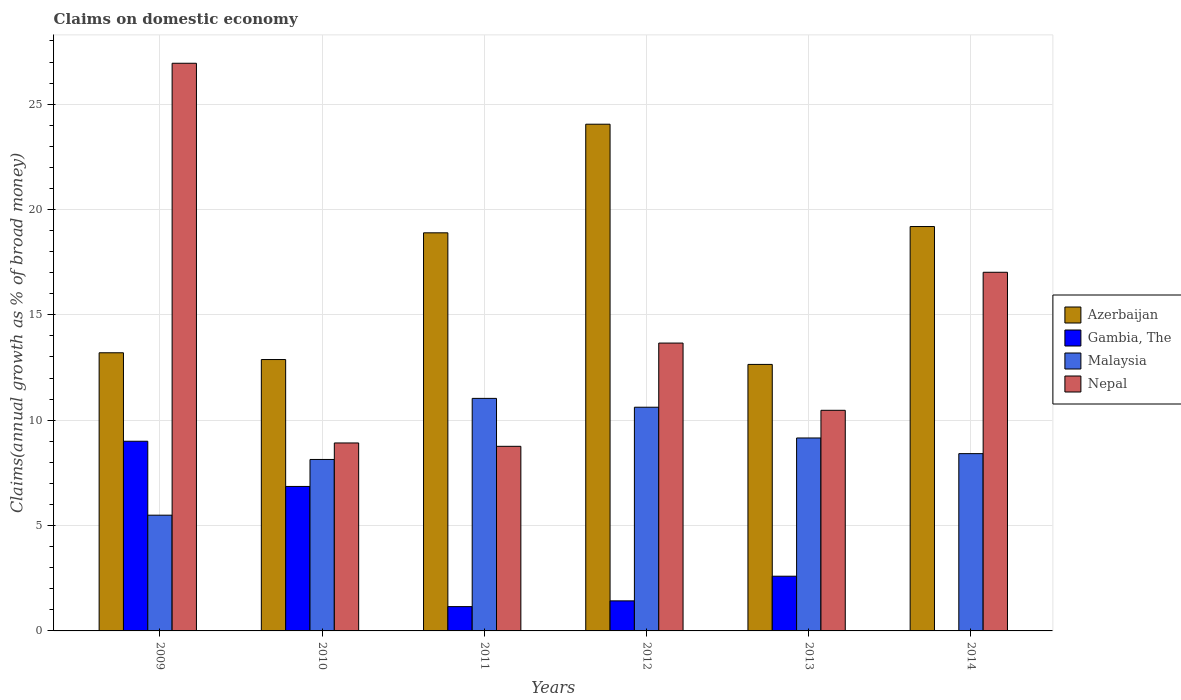How many different coloured bars are there?
Your answer should be compact. 4. How many groups of bars are there?
Your answer should be very brief. 6. How many bars are there on the 2nd tick from the right?
Offer a very short reply. 4. What is the label of the 5th group of bars from the left?
Offer a very short reply. 2013. What is the percentage of broad money claimed on domestic economy in Gambia, The in 2013?
Your answer should be compact. 2.6. Across all years, what is the maximum percentage of broad money claimed on domestic economy in Azerbaijan?
Your response must be concise. 24.05. Across all years, what is the minimum percentage of broad money claimed on domestic economy in Azerbaijan?
Your response must be concise. 12.65. What is the total percentage of broad money claimed on domestic economy in Nepal in the graph?
Ensure brevity in your answer.  85.77. What is the difference between the percentage of broad money claimed on domestic economy in Azerbaijan in 2010 and that in 2013?
Your answer should be compact. 0.23. What is the difference between the percentage of broad money claimed on domestic economy in Malaysia in 2009 and the percentage of broad money claimed on domestic economy in Gambia, The in 2013?
Provide a succinct answer. 2.9. What is the average percentage of broad money claimed on domestic economy in Azerbaijan per year?
Keep it short and to the point. 16.81. In the year 2010, what is the difference between the percentage of broad money claimed on domestic economy in Azerbaijan and percentage of broad money claimed on domestic economy in Gambia, The?
Your answer should be very brief. 6.02. What is the ratio of the percentage of broad money claimed on domestic economy in Malaysia in 2010 to that in 2014?
Make the answer very short. 0.97. Is the difference between the percentage of broad money claimed on domestic economy in Azerbaijan in 2011 and 2013 greater than the difference between the percentage of broad money claimed on domestic economy in Gambia, The in 2011 and 2013?
Provide a short and direct response. Yes. What is the difference between the highest and the second highest percentage of broad money claimed on domestic economy in Malaysia?
Your answer should be compact. 0.42. What is the difference between the highest and the lowest percentage of broad money claimed on domestic economy in Azerbaijan?
Offer a terse response. 11.4. In how many years, is the percentage of broad money claimed on domestic economy in Malaysia greater than the average percentage of broad money claimed on domestic economy in Malaysia taken over all years?
Make the answer very short. 3. How many bars are there?
Provide a short and direct response. 23. Does the graph contain grids?
Provide a short and direct response. Yes. Where does the legend appear in the graph?
Offer a very short reply. Center right. How are the legend labels stacked?
Offer a terse response. Vertical. What is the title of the graph?
Offer a terse response. Claims on domestic economy. What is the label or title of the Y-axis?
Offer a very short reply. Claims(annual growth as % of broad money). What is the Claims(annual growth as % of broad money) in Azerbaijan in 2009?
Your answer should be compact. 13.2. What is the Claims(annual growth as % of broad money) in Gambia, The in 2009?
Your response must be concise. 9. What is the Claims(annual growth as % of broad money) in Malaysia in 2009?
Your answer should be very brief. 5.49. What is the Claims(annual growth as % of broad money) of Nepal in 2009?
Give a very brief answer. 26.94. What is the Claims(annual growth as % of broad money) of Azerbaijan in 2010?
Provide a short and direct response. 12.88. What is the Claims(annual growth as % of broad money) in Gambia, The in 2010?
Offer a very short reply. 6.86. What is the Claims(annual growth as % of broad money) in Malaysia in 2010?
Offer a terse response. 8.14. What is the Claims(annual growth as % of broad money) in Nepal in 2010?
Provide a succinct answer. 8.92. What is the Claims(annual growth as % of broad money) of Azerbaijan in 2011?
Give a very brief answer. 18.89. What is the Claims(annual growth as % of broad money) of Gambia, The in 2011?
Your response must be concise. 1.15. What is the Claims(annual growth as % of broad money) of Malaysia in 2011?
Your answer should be very brief. 11.04. What is the Claims(annual growth as % of broad money) of Nepal in 2011?
Your answer should be compact. 8.76. What is the Claims(annual growth as % of broad money) of Azerbaijan in 2012?
Your answer should be compact. 24.05. What is the Claims(annual growth as % of broad money) in Gambia, The in 2012?
Provide a succinct answer. 1.43. What is the Claims(annual growth as % of broad money) of Malaysia in 2012?
Make the answer very short. 10.62. What is the Claims(annual growth as % of broad money) in Nepal in 2012?
Your answer should be compact. 13.66. What is the Claims(annual growth as % of broad money) in Azerbaijan in 2013?
Your response must be concise. 12.65. What is the Claims(annual growth as % of broad money) in Gambia, The in 2013?
Offer a terse response. 2.6. What is the Claims(annual growth as % of broad money) in Malaysia in 2013?
Your answer should be compact. 9.16. What is the Claims(annual growth as % of broad money) of Nepal in 2013?
Your response must be concise. 10.47. What is the Claims(annual growth as % of broad money) of Azerbaijan in 2014?
Your answer should be very brief. 19.19. What is the Claims(annual growth as % of broad money) of Gambia, The in 2014?
Offer a very short reply. 0. What is the Claims(annual growth as % of broad money) in Malaysia in 2014?
Your answer should be very brief. 8.41. What is the Claims(annual growth as % of broad money) of Nepal in 2014?
Ensure brevity in your answer.  17.02. Across all years, what is the maximum Claims(annual growth as % of broad money) in Azerbaijan?
Provide a succinct answer. 24.05. Across all years, what is the maximum Claims(annual growth as % of broad money) in Gambia, The?
Give a very brief answer. 9. Across all years, what is the maximum Claims(annual growth as % of broad money) in Malaysia?
Your answer should be very brief. 11.04. Across all years, what is the maximum Claims(annual growth as % of broad money) of Nepal?
Offer a very short reply. 26.94. Across all years, what is the minimum Claims(annual growth as % of broad money) in Azerbaijan?
Give a very brief answer. 12.65. Across all years, what is the minimum Claims(annual growth as % of broad money) in Gambia, The?
Provide a short and direct response. 0. Across all years, what is the minimum Claims(annual growth as % of broad money) in Malaysia?
Your answer should be compact. 5.49. Across all years, what is the minimum Claims(annual growth as % of broad money) of Nepal?
Keep it short and to the point. 8.76. What is the total Claims(annual growth as % of broad money) of Azerbaijan in the graph?
Offer a very short reply. 100.86. What is the total Claims(annual growth as % of broad money) in Gambia, The in the graph?
Provide a succinct answer. 21.03. What is the total Claims(annual growth as % of broad money) in Malaysia in the graph?
Provide a succinct answer. 52.85. What is the total Claims(annual growth as % of broad money) in Nepal in the graph?
Give a very brief answer. 85.77. What is the difference between the Claims(annual growth as % of broad money) in Azerbaijan in 2009 and that in 2010?
Give a very brief answer. 0.32. What is the difference between the Claims(annual growth as % of broad money) of Gambia, The in 2009 and that in 2010?
Offer a very short reply. 2.15. What is the difference between the Claims(annual growth as % of broad money) of Malaysia in 2009 and that in 2010?
Make the answer very short. -2.64. What is the difference between the Claims(annual growth as % of broad money) of Nepal in 2009 and that in 2010?
Your response must be concise. 18.02. What is the difference between the Claims(annual growth as % of broad money) of Azerbaijan in 2009 and that in 2011?
Offer a terse response. -5.69. What is the difference between the Claims(annual growth as % of broad money) in Gambia, The in 2009 and that in 2011?
Your answer should be compact. 7.85. What is the difference between the Claims(annual growth as % of broad money) in Malaysia in 2009 and that in 2011?
Your answer should be compact. -5.54. What is the difference between the Claims(annual growth as % of broad money) in Nepal in 2009 and that in 2011?
Ensure brevity in your answer.  18.18. What is the difference between the Claims(annual growth as % of broad money) of Azerbaijan in 2009 and that in 2012?
Your response must be concise. -10.85. What is the difference between the Claims(annual growth as % of broad money) of Gambia, The in 2009 and that in 2012?
Your answer should be compact. 7.58. What is the difference between the Claims(annual growth as % of broad money) in Malaysia in 2009 and that in 2012?
Provide a short and direct response. -5.12. What is the difference between the Claims(annual growth as % of broad money) in Nepal in 2009 and that in 2012?
Give a very brief answer. 13.28. What is the difference between the Claims(annual growth as % of broad money) of Azerbaijan in 2009 and that in 2013?
Your answer should be compact. 0.55. What is the difference between the Claims(annual growth as % of broad money) in Gambia, The in 2009 and that in 2013?
Offer a terse response. 6.41. What is the difference between the Claims(annual growth as % of broad money) in Malaysia in 2009 and that in 2013?
Ensure brevity in your answer.  -3.66. What is the difference between the Claims(annual growth as % of broad money) in Nepal in 2009 and that in 2013?
Offer a terse response. 16.47. What is the difference between the Claims(annual growth as % of broad money) in Azerbaijan in 2009 and that in 2014?
Your answer should be very brief. -5.99. What is the difference between the Claims(annual growth as % of broad money) in Malaysia in 2009 and that in 2014?
Offer a very short reply. -2.92. What is the difference between the Claims(annual growth as % of broad money) of Nepal in 2009 and that in 2014?
Ensure brevity in your answer.  9.92. What is the difference between the Claims(annual growth as % of broad money) of Azerbaijan in 2010 and that in 2011?
Your answer should be very brief. -6.01. What is the difference between the Claims(annual growth as % of broad money) of Gambia, The in 2010 and that in 2011?
Offer a terse response. 5.7. What is the difference between the Claims(annual growth as % of broad money) of Malaysia in 2010 and that in 2011?
Your response must be concise. -2.9. What is the difference between the Claims(annual growth as % of broad money) in Nepal in 2010 and that in 2011?
Offer a very short reply. 0.16. What is the difference between the Claims(annual growth as % of broad money) of Azerbaijan in 2010 and that in 2012?
Offer a very short reply. -11.17. What is the difference between the Claims(annual growth as % of broad money) of Gambia, The in 2010 and that in 2012?
Offer a terse response. 5.43. What is the difference between the Claims(annual growth as % of broad money) in Malaysia in 2010 and that in 2012?
Give a very brief answer. -2.48. What is the difference between the Claims(annual growth as % of broad money) of Nepal in 2010 and that in 2012?
Keep it short and to the point. -4.74. What is the difference between the Claims(annual growth as % of broad money) in Azerbaijan in 2010 and that in 2013?
Provide a succinct answer. 0.23. What is the difference between the Claims(annual growth as % of broad money) of Gambia, The in 2010 and that in 2013?
Your answer should be compact. 4.26. What is the difference between the Claims(annual growth as % of broad money) in Malaysia in 2010 and that in 2013?
Provide a succinct answer. -1.02. What is the difference between the Claims(annual growth as % of broad money) of Nepal in 2010 and that in 2013?
Keep it short and to the point. -1.55. What is the difference between the Claims(annual growth as % of broad money) in Azerbaijan in 2010 and that in 2014?
Ensure brevity in your answer.  -6.31. What is the difference between the Claims(annual growth as % of broad money) in Malaysia in 2010 and that in 2014?
Keep it short and to the point. -0.28. What is the difference between the Claims(annual growth as % of broad money) in Nepal in 2010 and that in 2014?
Provide a succinct answer. -8.1. What is the difference between the Claims(annual growth as % of broad money) of Azerbaijan in 2011 and that in 2012?
Provide a short and direct response. -5.16. What is the difference between the Claims(annual growth as % of broad money) in Gambia, The in 2011 and that in 2012?
Keep it short and to the point. -0.27. What is the difference between the Claims(annual growth as % of broad money) in Malaysia in 2011 and that in 2012?
Make the answer very short. 0.42. What is the difference between the Claims(annual growth as % of broad money) of Nepal in 2011 and that in 2012?
Your response must be concise. -4.9. What is the difference between the Claims(annual growth as % of broad money) of Azerbaijan in 2011 and that in 2013?
Offer a very short reply. 6.25. What is the difference between the Claims(annual growth as % of broad money) of Gambia, The in 2011 and that in 2013?
Your answer should be very brief. -1.44. What is the difference between the Claims(annual growth as % of broad money) in Malaysia in 2011 and that in 2013?
Your answer should be very brief. 1.88. What is the difference between the Claims(annual growth as % of broad money) in Nepal in 2011 and that in 2013?
Keep it short and to the point. -1.71. What is the difference between the Claims(annual growth as % of broad money) in Azerbaijan in 2011 and that in 2014?
Your response must be concise. -0.3. What is the difference between the Claims(annual growth as % of broad money) in Malaysia in 2011 and that in 2014?
Keep it short and to the point. 2.62. What is the difference between the Claims(annual growth as % of broad money) of Nepal in 2011 and that in 2014?
Provide a succinct answer. -8.26. What is the difference between the Claims(annual growth as % of broad money) of Azerbaijan in 2012 and that in 2013?
Your response must be concise. 11.4. What is the difference between the Claims(annual growth as % of broad money) of Gambia, The in 2012 and that in 2013?
Give a very brief answer. -1.17. What is the difference between the Claims(annual growth as % of broad money) of Malaysia in 2012 and that in 2013?
Offer a terse response. 1.46. What is the difference between the Claims(annual growth as % of broad money) of Nepal in 2012 and that in 2013?
Your answer should be compact. 3.19. What is the difference between the Claims(annual growth as % of broad money) in Azerbaijan in 2012 and that in 2014?
Give a very brief answer. 4.86. What is the difference between the Claims(annual growth as % of broad money) of Malaysia in 2012 and that in 2014?
Your response must be concise. 2.2. What is the difference between the Claims(annual growth as % of broad money) of Nepal in 2012 and that in 2014?
Provide a succinct answer. -3.36. What is the difference between the Claims(annual growth as % of broad money) in Azerbaijan in 2013 and that in 2014?
Your response must be concise. -6.54. What is the difference between the Claims(annual growth as % of broad money) in Malaysia in 2013 and that in 2014?
Offer a very short reply. 0.74. What is the difference between the Claims(annual growth as % of broad money) in Nepal in 2013 and that in 2014?
Your answer should be very brief. -6.55. What is the difference between the Claims(annual growth as % of broad money) in Azerbaijan in 2009 and the Claims(annual growth as % of broad money) in Gambia, The in 2010?
Ensure brevity in your answer.  6.34. What is the difference between the Claims(annual growth as % of broad money) of Azerbaijan in 2009 and the Claims(annual growth as % of broad money) of Malaysia in 2010?
Provide a succinct answer. 5.06. What is the difference between the Claims(annual growth as % of broad money) of Azerbaijan in 2009 and the Claims(annual growth as % of broad money) of Nepal in 2010?
Provide a short and direct response. 4.28. What is the difference between the Claims(annual growth as % of broad money) of Gambia, The in 2009 and the Claims(annual growth as % of broad money) of Malaysia in 2010?
Offer a very short reply. 0.86. What is the difference between the Claims(annual growth as % of broad money) of Gambia, The in 2009 and the Claims(annual growth as % of broad money) of Nepal in 2010?
Your answer should be very brief. 0.08. What is the difference between the Claims(annual growth as % of broad money) in Malaysia in 2009 and the Claims(annual growth as % of broad money) in Nepal in 2010?
Provide a succinct answer. -3.43. What is the difference between the Claims(annual growth as % of broad money) in Azerbaijan in 2009 and the Claims(annual growth as % of broad money) in Gambia, The in 2011?
Your answer should be very brief. 12.05. What is the difference between the Claims(annual growth as % of broad money) in Azerbaijan in 2009 and the Claims(annual growth as % of broad money) in Malaysia in 2011?
Provide a short and direct response. 2.16. What is the difference between the Claims(annual growth as % of broad money) in Azerbaijan in 2009 and the Claims(annual growth as % of broad money) in Nepal in 2011?
Your answer should be compact. 4.44. What is the difference between the Claims(annual growth as % of broad money) of Gambia, The in 2009 and the Claims(annual growth as % of broad money) of Malaysia in 2011?
Your response must be concise. -2.03. What is the difference between the Claims(annual growth as % of broad money) of Gambia, The in 2009 and the Claims(annual growth as % of broad money) of Nepal in 2011?
Offer a very short reply. 0.24. What is the difference between the Claims(annual growth as % of broad money) in Malaysia in 2009 and the Claims(annual growth as % of broad money) in Nepal in 2011?
Offer a very short reply. -3.27. What is the difference between the Claims(annual growth as % of broad money) in Azerbaijan in 2009 and the Claims(annual growth as % of broad money) in Gambia, The in 2012?
Provide a succinct answer. 11.77. What is the difference between the Claims(annual growth as % of broad money) of Azerbaijan in 2009 and the Claims(annual growth as % of broad money) of Malaysia in 2012?
Offer a very short reply. 2.58. What is the difference between the Claims(annual growth as % of broad money) of Azerbaijan in 2009 and the Claims(annual growth as % of broad money) of Nepal in 2012?
Ensure brevity in your answer.  -0.46. What is the difference between the Claims(annual growth as % of broad money) in Gambia, The in 2009 and the Claims(annual growth as % of broad money) in Malaysia in 2012?
Offer a very short reply. -1.61. What is the difference between the Claims(annual growth as % of broad money) in Gambia, The in 2009 and the Claims(annual growth as % of broad money) in Nepal in 2012?
Offer a terse response. -4.66. What is the difference between the Claims(annual growth as % of broad money) of Malaysia in 2009 and the Claims(annual growth as % of broad money) of Nepal in 2012?
Provide a succinct answer. -8.17. What is the difference between the Claims(annual growth as % of broad money) in Azerbaijan in 2009 and the Claims(annual growth as % of broad money) in Gambia, The in 2013?
Your response must be concise. 10.6. What is the difference between the Claims(annual growth as % of broad money) of Azerbaijan in 2009 and the Claims(annual growth as % of broad money) of Malaysia in 2013?
Ensure brevity in your answer.  4.04. What is the difference between the Claims(annual growth as % of broad money) in Azerbaijan in 2009 and the Claims(annual growth as % of broad money) in Nepal in 2013?
Provide a short and direct response. 2.73. What is the difference between the Claims(annual growth as % of broad money) of Gambia, The in 2009 and the Claims(annual growth as % of broad money) of Malaysia in 2013?
Provide a short and direct response. -0.15. What is the difference between the Claims(annual growth as % of broad money) of Gambia, The in 2009 and the Claims(annual growth as % of broad money) of Nepal in 2013?
Give a very brief answer. -1.47. What is the difference between the Claims(annual growth as % of broad money) in Malaysia in 2009 and the Claims(annual growth as % of broad money) in Nepal in 2013?
Keep it short and to the point. -4.98. What is the difference between the Claims(annual growth as % of broad money) of Azerbaijan in 2009 and the Claims(annual growth as % of broad money) of Malaysia in 2014?
Ensure brevity in your answer.  4.79. What is the difference between the Claims(annual growth as % of broad money) in Azerbaijan in 2009 and the Claims(annual growth as % of broad money) in Nepal in 2014?
Give a very brief answer. -3.82. What is the difference between the Claims(annual growth as % of broad money) in Gambia, The in 2009 and the Claims(annual growth as % of broad money) in Malaysia in 2014?
Ensure brevity in your answer.  0.59. What is the difference between the Claims(annual growth as % of broad money) of Gambia, The in 2009 and the Claims(annual growth as % of broad money) of Nepal in 2014?
Keep it short and to the point. -8.02. What is the difference between the Claims(annual growth as % of broad money) in Malaysia in 2009 and the Claims(annual growth as % of broad money) in Nepal in 2014?
Keep it short and to the point. -11.53. What is the difference between the Claims(annual growth as % of broad money) in Azerbaijan in 2010 and the Claims(annual growth as % of broad money) in Gambia, The in 2011?
Make the answer very short. 11.73. What is the difference between the Claims(annual growth as % of broad money) in Azerbaijan in 2010 and the Claims(annual growth as % of broad money) in Malaysia in 2011?
Offer a very short reply. 1.84. What is the difference between the Claims(annual growth as % of broad money) in Azerbaijan in 2010 and the Claims(annual growth as % of broad money) in Nepal in 2011?
Provide a short and direct response. 4.12. What is the difference between the Claims(annual growth as % of broad money) in Gambia, The in 2010 and the Claims(annual growth as % of broad money) in Malaysia in 2011?
Give a very brief answer. -4.18. What is the difference between the Claims(annual growth as % of broad money) in Gambia, The in 2010 and the Claims(annual growth as % of broad money) in Nepal in 2011?
Give a very brief answer. -1.9. What is the difference between the Claims(annual growth as % of broad money) of Malaysia in 2010 and the Claims(annual growth as % of broad money) of Nepal in 2011?
Give a very brief answer. -0.62. What is the difference between the Claims(annual growth as % of broad money) of Azerbaijan in 2010 and the Claims(annual growth as % of broad money) of Gambia, The in 2012?
Provide a succinct answer. 11.45. What is the difference between the Claims(annual growth as % of broad money) in Azerbaijan in 2010 and the Claims(annual growth as % of broad money) in Malaysia in 2012?
Make the answer very short. 2.26. What is the difference between the Claims(annual growth as % of broad money) of Azerbaijan in 2010 and the Claims(annual growth as % of broad money) of Nepal in 2012?
Give a very brief answer. -0.78. What is the difference between the Claims(annual growth as % of broad money) of Gambia, The in 2010 and the Claims(annual growth as % of broad money) of Malaysia in 2012?
Your answer should be compact. -3.76. What is the difference between the Claims(annual growth as % of broad money) in Gambia, The in 2010 and the Claims(annual growth as % of broad money) in Nepal in 2012?
Keep it short and to the point. -6.8. What is the difference between the Claims(annual growth as % of broad money) in Malaysia in 2010 and the Claims(annual growth as % of broad money) in Nepal in 2012?
Provide a short and direct response. -5.52. What is the difference between the Claims(annual growth as % of broad money) of Azerbaijan in 2010 and the Claims(annual growth as % of broad money) of Gambia, The in 2013?
Provide a short and direct response. 10.28. What is the difference between the Claims(annual growth as % of broad money) of Azerbaijan in 2010 and the Claims(annual growth as % of broad money) of Malaysia in 2013?
Your answer should be very brief. 3.72. What is the difference between the Claims(annual growth as % of broad money) in Azerbaijan in 2010 and the Claims(annual growth as % of broad money) in Nepal in 2013?
Give a very brief answer. 2.41. What is the difference between the Claims(annual growth as % of broad money) of Gambia, The in 2010 and the Claims(annual growth as % of broad money) of Malaysia in 2013?
Offer a very short reply. -2.3. What is the difference between the Claims(annual growth as % of broad money) in Gambia, The in 2010 and the Claims(annual growth as % of broad money) in Nepal in 2013?
Make the answer very short. -3.61. What is the difference between the Claims(annual growth as % of broad money) of Malaysia in 2010 and the Claims(annual growth as % of broad money) of Nepal in 2013?
Keep it short and to the point. -2.33. What is the difference between the Claims(annual growth as % of broad money) of Azerbaijan in 2010 and the Claims(annual growth as % of broad money) of Malaysia in 2014?
Keep it short and to the point. 4.47. What is the difference between the Claims(annual growth as % of broad money) in Azerbaijan in 2010 and the Claims(annual growth as % of broad money) in Nepal in 2014?
Your response must be concise. -4.14. What is the difference between the Claims(annual growth as % of broad money) of Gambia, The in 2010 and the Claims(annual growth as % of broad money) of Malaysia in 2014?
Provide a short and direct response. -1.56. What is the difference between the Claims(annual growth as % of broad money) in Gambia, The in 2010 and the Claims(annual growth as % of broad money) in Nepal in 2014?
Offer a very short reply. -10.16. What is the difference between the Claims(annual growth as % of broad money) in Malaysia in 2010 and the Claims(annual growth as % of broad money) in Nepal in 2014?
Offer a very short reply. -8.88. What is the difference between the Claims(annual growth as % of broad money) of Azerbaijan in 2011 and the Claims(annual growth as % of broad money) of Gambia, The in 2012?
Keep it short and to the point. 17.47. What is the difference between the Claims(annual growth as % of broad money) in Azerbaijan in 2011 and the Claims(annual growth as % of broad money) in Malaysia in 2012?
Offer a very short reply. 8.28. What is the difference between the Claims(annual growth as % of broad money) in Azerbaijan in 2011 and the Claims(annual growth as % of broad money) in Nepal in 2012?
Give a very brief answer. 5.23. What is the difference between the Claims(annual growth as % of broad money) of Gambia, The in 2011 and the Claims(annual growth as % of broad money) of Malaysia in 2012?
Your answer should be very brief. -9.46. What is the difference between the Claims(annual growth as % of broad money) of Gambia, The in 2011 and the Claims(annual growth as % of broad money) of Nepal in 2012?
Make the answer very short. -12.51. What is the difference between the Claims(annual growth as % of broad money) in Malaysia in 2011 and the Claims(annual growth as % of broad money) in Nepal in 2012?
Make the answer very short. -2.63. What is the difference between the Claims(annual growth as % of broad money) in Azerbaijan in 2011 and the Claims(annual growth as % of broad money) in Gambia, The in 2013?
Provide a short and direct response. 16.3. What is the difference between the Claims(annual growth as % of broad money) of Azerbaijan in 2011 and the Claims(annual growth as % of broad money) of Malaysia in 2013?
Your response must be concise. 9.74. What is the difference between the Claims(annual growth as % of broad money) of Azerbaijan in 2011 and the Claims(annual growth as % of broad money) of Nepal in 2013?
Provide a short and direct response. 8.42. What is the difference between the Claims(annual growth as % of broad money) in Gambia, The in 2011 and the Claims(annual growth as % of broad money) in Malaysia in 2013?
Your answer should be very brief. -8. What is the difference between the Claims(annual growth as % of broad money) of Gambia, The in 2011 and the Claims(annual growth as % of broad money) of Nepal in 2013?
Your response must be concise. -9.32. What is the difference between the Claims(annual growth as % of broad money) in Malaysia in 2011 and the Claims(annual growth as % of broad money) in Nepal in 2013?
Give a very brief answer. 0.57. What is the difference between the Claims(annual growth as % of broad money) in Azerbaijan in 2011 and the Claims(annual growth as % of broad money) in Malaysia in 2014?
Keep it short and to the point. 10.48. What is the difference between the Claims(annual growth as % of broad money) of Azerbaijan in 2011 and the Claims(annual growth as % of broad money) of Nepal in 2014?
Your response must be concise. 1.87. What is the difference between the Claims(annual growth as % of broad money) in Gambia, The in 2011 and the Claims(annual growth as % of broad money) in Malaysia in 2014?
Provide a succinct answer. -7.26. What is the difference between the Claims(annual growth as % of broad money) of Gambia, The in 2011 and the Claims(annual growth as % of broad money) of Nepal in 2014?
Provide a succinct answer. -15.87. What is the difference between the Claims(annual growth as % of broad money) in Malaysia in 2011 and the Claims(annual growth as % of broad money) in Nepal in 2014?
Keep it short and to the point. -5.99. What is the difference between the Claims(annual growth as % of broad money) in Azerbaijan in 2012 and the Claims(annual growth as % of broad money) in Gambia, The in 2013?
Provide a succinct answer. 21.45. What is the difference between the Claims(annual growth as % of broad money) of Azerbaijan in 2012 and the Claims(annual growth as % of broad money) of Malaysia in 2013?
Keep it short and to the point. 14.89. What is the difference between the Claims(annual growth as % of broad money) in Azerbaijan in 2012 and the Claims(annual growth as % of broad money) in Nepal in 2013?
Provide a succinct answer. 13.58. What is the difference between the Claims(annual growth as % of broad money) in Gambia, The in 2012 and the Claims(annual growth as % of broad money) in Malaysia in 2013?
Your response must be concise. -7.73. What is the difference between the Claims(annual growth as % of broad money) in Gambia, The in 2012 and the Claims(annual growth as % of broad money) in Nepal in 2013?
Your response must be concise. -9.04. What is the difference between the Claims(annual growth as % of broad money) of Malaysia in 2012 and the Claims(annual growth as % of broad money) of Nepal in 2013?
Make the answer very short. 0.15. What is the difference between the Claims(annual growth as % of broad money) of Azerbaijan in 2012 and the Claims(annual growth as % of broad money) of Malaysia in 2014?
Offer a terse response. 15.63. What is the difference between the Claims(annual growth as % of broad money) of Azerbaijan in 2012 and the Claims(annual growth as % of broad money) of Nepal in 2014?
Offer a very short reply. 7.03. What is the difference between the Claims(annual growth as % of broad money) of Gambia, The in 2012 and the Claims(annual growth as % of broad money) of Malaysia in 2014?
Keep it short and to the point. -6.99. What is the difference between the Claims(annual growth as % of broad money) in Gambia, The in 2012 and the Claims(annual growth as % of broad money) in Nepal in 2014?
Your response must be concise. -15.59. What is the difference between the Claims(annual growth as % of broad money) in Malaysia in 2012 and the Claims(annual growth as % of broad money) in Nepal in 2014?
Ensure brevity in your answer.  -6.41. What is the difference between the Claims(annual growth as % of broad money) of Azerbaijan in 2013 and the Claims(annual growth as % of broad money) of Malaysia in 2014?
Provide a short and direct response. 4.23. What is the difference between the Claims(annual growth as % of broad money) of Azerbaijan in 2013 and the Claims(annual growth as % of broad money) of Nepal in 2014?
Give a very brief answer. -4.37. What is the difference between the Claims(annual growth as % of broad money) of Gambia, The in 2013 and the Claims(annual growth as % of broad money) of Malaysia in 2014?
Ensure brevity in your answer.  -5.82. What is the difference between the Claims(annual growth as % of broad money) in Gambia, The in 2013 and the Claims(annual growth as % of broad money) in Nepal in 2014?
Your answer should be compact. -14.42. What is the difference between the Claims(annual growth as % of broad money) in Malaysia in 2013 and the Claims(annual growth as % of broad money) in Nepal in 2014?
Your response must be concise. -7.86. What is the average Claims(annual growth as % of broad money) in Azerbaijan per year?
Offer a terse response. 16.81. What is the average Claims(annual growth as % of broad money) in Gambia, The per year?
Provide a short and direct response. 3.51. What is the average Claims(annual growth as % of broad money) in Malaysia per year?
Ensure brevity in your answer.  8.81. What is the average Claims(annual growth as % of broad money) of Nepal per year?
Give a very brief answer. 14.3. In the year 2009, what is the difference between the Claims(annual growth as % of broad money) in Azerbaijan and Claims(annual growth as % of broad money) in Gambia, The?
Offer a very short reply. 4.2. In the year 2009, what is the difference between the Claims(annual growth as % of broad money) of Azerbaijan and Claims(annual growth as % of broad money) of Malaysia?
Offer a very short reply. 7.71. In the year 2009, what is the difference between the Claims(annual growth as % of broad money) of Azerbaijan and Claims(annual growth as % of broad money) of Nepal?
Offer a terse response. -13.74. In the year 2009, what is the difference between the Claims(annual growth as % of broad money) in Gambia, The and Claims(annual growth as % of broad money) in Malaysia?
Provide a short and direct response. 3.51. In the year 2009, what is the difference between the Claims(annual growth as % of broad money) of Gambia, The and Claims(annual growth as % of broad money) of Nepal?
Make the answer very short. -17.94. In the year 2009, what is the difference between the Claims(annual growth as % of broad money) of Malaysia and Claims(annual growth as % of broad money) of Nepal?
Give a very brief answer. -21.45. In the year 2010, what is the difference between the Claims(annual growth as % of broad money) in Azerbaijan and Claims(annual growth as % of broad money) in Gambia, The?
Make the answer very short. 6.02. In the year 2010, what is the difference between the Claims(annual growth as % of broad money) of Azerbaijan and Claims(annual growth as % of broad money) of Malaysia?
Ensure brevity in your answer.  4.74. In the year 2010, what is the difference between the Claims(annual growth as % of broad money) in Azerbaijan and Claims(annual growth as % of broad money) in Nepal?
Provide a succinct answer. 3.96. In the year 2010, what is the difference between the Claims(annual growth as % of broad money) in Gambia, The and Claims(annual growth as % of broad money) in Malaysia?
Your answer should be very brief. -1.28. In the year 2010, what is the difference between the Claims(annual growth as % of broad money) of Gambia, The and Claims(annual growth as % of broad money) of Nepal?
Offer a terse response. -2.06. In the year 2010, what is the difference between the Claims(annual growth as % of broad money) of Malaysia and Claims(annual growth as % of broad money) of Nepal?
Your response must be concise. -0.78. In the year 2011, what is the difference between the Claims(annual growth as % of broad money) in Azerbaijan and Claims(annual growth as % of broad money) in Gambia, The?
Keep it short and to the point. 17.74. In the year 2011, what is the difference between the Claims(annual growth as % of broad money) in Azerbaijan and Claims(annual growth as % of broad money) in Malaysia?
Provide a succinct answer. 7.86. In the year 2011, what is the difference between the Claims(annual growth as % of broad money) of Azerbaijan and Claims(annual growth as % of broad money) of Nepal?
Your response must be concise. 10.13. In the year 2011, what is the difference between the Claims(annual growth as % of broad money) in Gambia, The and Claims(annual growth as % of broad money) in Malaysia?
Your answer should be compact. -9.88. In the year 2011, what is the difference between the Claims(annual growth as % of broad money) in Gambia, The and Claims(annual growth as % of broad money) in Nepal?
Provide a short and direct response. -7.61. In the year 2011, what is the difference between the Claims(annual growth as % of broad money) in Malaysia and Claims(annual growth as % of broad money) in Nepal?
Make the answer very short. 2.27. In the year 2012, what is the difference between the Claims(annual growth as % of broad money) of Azerbaijan and Claims(annual growth as % of broad money) of Gambia, The?
Your answer should be very brief. 22.62. In the year 2012, what is the difference between the Claims(annual growth as % of broad money) in Azerbaijan and Claims(annual growth as % of broad money) in Malaysia?
Make the answer very short. 13.43. In the year 2012, what is the difference between the Claims(annual growth as % of broad money) of Azerbaijan and Claims(annual growth as % of broad money) of Nepal?
Offer a terse response. 10.39. In the year 2012, what is the difference between the Claims(annual growth as % of broad money) of Gambia, The and Claims(annual growth as % of broad money) of Malaysia?
Ensure brevity in your answer.  -9.19. In the year 2012, what is the difference between the Claims(annual growth as % of broad money) in Gambia, The and Claims(annual growth as % of broad money) in Nepal?
Your answer should be compact. -12.23. In the year 2012, what is the difference between the Claims(annual growth as % of broad money) of Malaysia and Claims(annual growth as % of broad money) of Nepal?
Offer a very short reply. -3.05. In the year 2013, what is the difference between the Claims(annual growth as % of broad money) in Azerbaijan and Claims(annual growth as % of broad money) in Gambia, The?
Ensure brevity in your answer.  10.05. In the year 2013, what is the difference between the Claims(annual growth as % of broad money) in Azerbaijan and Claims(annual growth as % of broad money) in Malaysia?
Keep it short and to the point. 3.49. In the year 2013, what is the difference between the Claims(annual growth as % of broad money) in Azerbaijan and Claims(annual growth as % of broad money) in Nepal?
Provide a short and direct response. 2.18. In the year 2013, what is the difference between the Claims(annual growth as % of broad money) of Gambia, The and Claims(annual growth as % of broad money) of Malaysia?
Your answer should be compact. -6.56. In the year 2013, what is the difference between the Claims(annual growth as % of broad money) of Gambia, The and Claims(annual growth as % of broad money) of Nepal?
Give a very brief answer. -7.87. In the year 2013, what is the difference between the Claims(annual growth as % of broad money) of Malaysia and Claims(annual growth as % of broad money) of Nepal?
Your answer should be compact. -1.31. In the year 2014, what is the difference between the Claims(annual growth as % of broad money) in Azerbaijan and Claims(annual growth as % of broad money) in Malaysia?
Ensure brevity in your answer.  10.78. In the year 2014, what is the difference between the Claims(annual growth as % of broad money) of Azerbaijan and Claims(annual growth as % of broad money) of Nepal?
Provide a succinct answer. 2.17. In the year 2014, what is the difference between the Claims(annual growth as % of broad money) in Malaysia and Claims(annual growth as % of broad money) in Nepal?
Give a very brief answer. -8.61. What is the ratio of the Claims(annual growth as % of broad money) of Azerbaijan in 2009 to that in 2010?
Make the answer very short. 1.02. What is the ratio of the Claims(annual growth as % of broad money) of Gambia, The in 2009 to that in 2010?
Offer a terse response. 1.31. What is the ratio of the Claims(annual growth as % of broad money) of Malaysia in 2009 to that in 2010?
Keep it short and to the point. 0.68. What is the ratio of the Claims(annual growth as % of broad money) of Nepal in 2009 to that in 2010?
Make the answer very short. 3.02. What is the ratio of the Claims(annual growth as % of broad money) of Azerbaijan in 2009 to that in 2011?
Make the answer very short. 0.7. What is the ratio of the Claims(annual growth as % of broad money) in Gambia, The in 2009 to that in 2011?
Your answer should be compact. 7.81. What is the ratio of the Claims(annual growth as % of broad money) of Malaysia in 2009 to that in 2011?
Provide a short and direct response. 0.5. What is the ratio of the Claims(annual growth as % of broad money) in Nepal in 2009 to that in 2011?
Your response must be concise. 3.08. What is the ratio of the Claims(annual growth as % of broad money) in Azerbaijan in 2009 to that in 2012?
Make the answer very short. 0.55. What is the ratio of the Claims(annual growth as % of broad money) in Gambia, The in 2009 to that in 2012?
Provide a succinct answer. 6.31. What is the ratio of the Claims(annual growth as % of broad money) in Malaysia in 2009 to that in 2012?
Provide a short and direct response. 0.52. What is the ratio of the Claims(annual growth as % of broad money) of Nepal in 2009 to that in 2012?
Ensure brevity in your answer.  1.97. What is the ratio of the Claims(annual growth as % of broad money) of Azerbaijan in 2009 to that in 2013?
Provide a succinct answer. 1.04. What is the ratio of the Claims(annual growth as % of broad money) of Gambia, The in 2009 to that in 2013?
Your answer should be very brief. 3.47. What is the ratio of the Claims(annual growth as % of broad money) in Malaysia in 2009 to that in 2013?
Provide a short and direct response. 0.6. What is the ratio of the Claims(annual growth as % of broad money) of Nepal in 2009 to that in 2013?
Your answer should be very brief. 2.57. What is the ratio of the Claims(annual growth as % of broad money) of Azerbaijan in 2009 to that in 2014?
Your response must be concise. 0.69. What is the ratio of the Claims(annual growth as % of broad money) of Malaysia in 2009 to that in 2014?
Provide a short and direct response. 0.65. What is the ratio of the Claims(annual growth as % of broad money) in Nepal in 2009 to that in 2014?
Provide a succinct answer. 1.58. What is the ratio of the Claims(annual growth as % of broad money) of Azerbaijan in 2010 to that in 2011?
Provide a succinct answer. 0.68. What is the ratio of the Claims(annual growth as % of broad money) in Gambia, The in 2010 to that in 2011?
Your answer should be compact. 5.95. What is the ratio of the Claims(annual growth as % of broad money) of Malaysia in 2010 to that in 2011?
Offer a very short reply. 0.74. What is the ratio of the Claims(annual growth as % of broad money) in Nepal in 2010 to that in 2011?
Make the answer very short. 1.02. What is the ratio of the Claims(annual growth as % of broad money) of Azerbaijan in 2010 to that in 2012?
Your response must be concise. 0.54. What is the ratio of the Claims(annual growth as % of broad money) in Gambia, The in 2010 to that in 2012?
Make the answer very short. 4.81. What is the ratio of the Claims(annual growth as % of broad money) in Malaysia in 2010 to that in 2012?
Provide a succinct answer. 0.77. What is the ratio of the Claims(annual growth as % of broad money) of Nepal in 2010 to that in 2012?
Keep it short and to the point. 0.65. What is the ratio of the Claims(annual growth as % of broad money) of Azerbaijan in 2010 to that in 2013?
Offer a terse response. 1.02. What is the ratio of the Claims(annual growth as % of broad money) in Gambia, The in 2010 to that in 2013?
Offer a terse response. 2.64. What is the ratio of the Claims(annual growth as % of broad money) of Malaysia in 2010 to that in 2013?
Make the answer very short. 0.89. What is the ratio of the Claims(annual growth as % of broad money) of Nepal in 2010 to that in 2013?
Your response must be concise. 0.85. What is the ratio of the Claims(annual growth as % of broad money) of Azerbaijan in 2010 to that in 2014?
Your response must be concise. 0.67. What is the ratio of the Claims(annual growth as % of broad money) of Malaysia in 2010 to that in 2014?
Make the answer very short. 0.97. What is the ratio of the Claims(annual growth as % of broad money) in Nepal in 2010 to that in 2014?
Your answer should be compact. 0.52. What is the ratio of the Claims(annual growth as % of broad money) of Azerbaijan in 2011 to that in 2012?
Make the answer very short. 0.79. What is the ratio of the Claims(annual growth as % of broad money) of Gambia, The in 2011 to that in 2012?
Ensure brevity in your answer.  0.81. What is the ratio of the Claims(annual growth as % of broad money) of Malaysia in 2011 to that in 2012?
Provide a short and direct response. 1.04. What is the ratio of the Claims(annual growth as % of broad money) in Nepal in 2011 to that in 2012?
Give a very brief answer. 0.64. What is the ratio of the Claims(annual growth as % of broad money) in Azerbaijan in 2011 to that in 2013?
Offer a terse response. 1.49. What is the ratio of the Claims(annual growth as % of broad money) in Gambia, The in 2011 to that in 2013?
Offer a terse response. 0.44. What is the ratio of the Claims(annual growth as % of broad money) in Malaysia in 2011 to that in 2013?
Keep it short and to the point. 1.21. What is the ratio of the Claims(annual growth as % of broad money) of Nepal in 2011 to that in 2013?
Give a very brief answer. 0.84. What is the ratio of the Claims(annual growth as % of broad money) in Azerbaijan in 2011 to that in 2014?
Provide a short and direct response. 0.98. What is the ratio of the Claims(annual growth as % of broad money) of Malaysia in 2011 to that in 2014?
Provide a short and direct response. 1.31. What is the ratio of the Claims(annual growth as % of broad money) in Nepal in 2011 to that in 2014?
Ensure brevity in your answer.  0.51. What is the ratio of the Claims(annual growth as % of broad money) in Azerbaijan in 2012 to that in 2013?
Ensure brevity in your answer.  1.9. What is the ratio of the Claims(annual growth as % of broad money) of Gambia, The in 2012 to that in 2013?
Your answer should be compact. 0.55. What is the ratio of the Claims(annual growth as % of broad money) of Malaysia in 2012 to that in 2013?
Give a very brief answer. 1.16. What is the ratio of the Claims(annual growth as % of broad money) in Nepal in 2012 to that in 2013?
Provide a short and direct response. 1.3. What is the ratio of the Claims(annual growth as % of broad money) of Azerbaijan in 2012 to that in 2014?
Your answer should be very brief. 1.25. What is the ratio of the Claims(annual growth as % of broad money) of Malaysia in 2012 to that in 2014?
Provide a succinct answer. 1.26. What is the ratio of the Claims(annual growth as % of broad money) in Nepal in 2012 to that in 2014?
Provide a succinct answer. 0.8. What is the ratio of the Claims(annual growth as % of broad money) in Azerbaijan in 2013 to that in 2014?
Make the answer very short. 0.66. What is the ratio of the Claims(annual growth as % of broad money) in Malaysia in 2013 to that in 2014?
Offer a very short reply. 1.09. What is the ratio of the Claims(annual growth as % of broad money) of Nepal in 2013 to that in 2014?
Your answer should be compact. 0.62. What is the difference between the highest and the second highest Claims(annual growth as % of broad money) of Azerbaijan?
Provide a succinct answer. 4.86. What is the difference between the highest and the second highest Claims(annual growth as % of broad money) in Gambia, The?
Provide a short and direct response. 2.15. What is the difference between the highest and the second highest Claims(annual growth as % of broad money) of Malaysia?
Ensure brevity in your answer.  0.42. What is the difference between the highest and the second highest Claims(annual growth as % of broad money) in Nepal?
Give a very brief answer. 9.92. What is the difference between the highest and the lowest Claims(annual growth as % of broad money) of Gambia, The?
Offer a terse response. 9. What is the difference between the highest and the lowest Claims(annual growth as % of broad money) in Malaysia?
Provide a short and direct response. 5.54. What is the difference between the highest and the lowest Claims(annual growth as % of broad money) of Nepal?
Give a very brief answer. 18.18. 